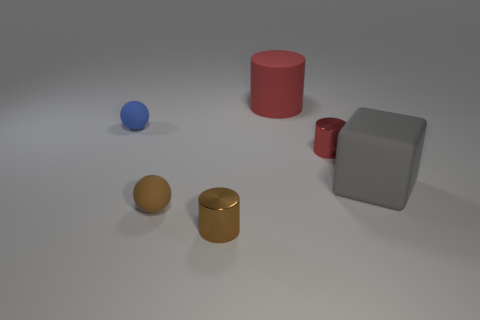Add 2 tiny rubber spheres. How many objects exist? 8 Subtract all spheres. How many objects are left? 4 Add 2 large cyan metallic spheres. How many large cyan metallic spheres exist? 2 Subtract 0 cyan cylinders. How many objects are left? 6 Subtract all red metal cylinders. Subtract all red metal things. How many objects are left? 4 Add 4 big gray matte cubes. How many big gray matte cubes are left? 5 